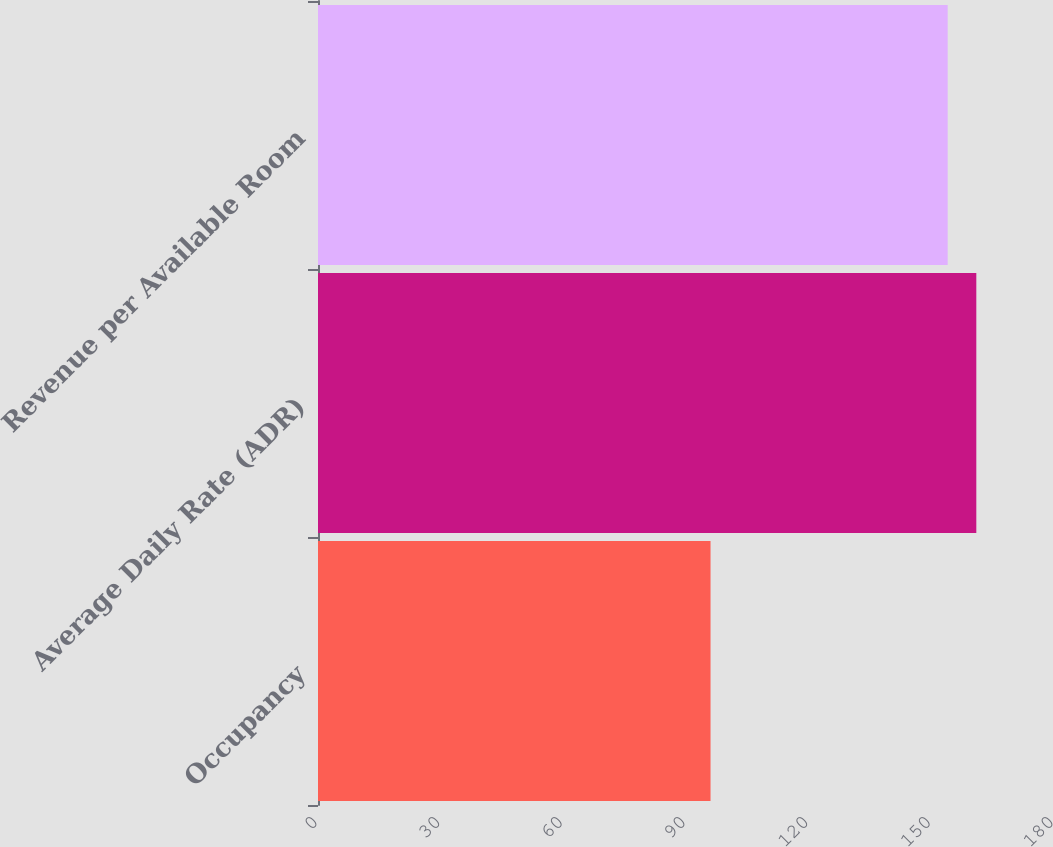<chart> <loc_0><loc_0><loc_500><loc_500><bar_chart><fcel>Occupancy<fcel>Average Daily Rate (ADR)<fcel>Revenue per Available Room<nl><fcel>96<fcel>161<fcel>154<nl></chart> 